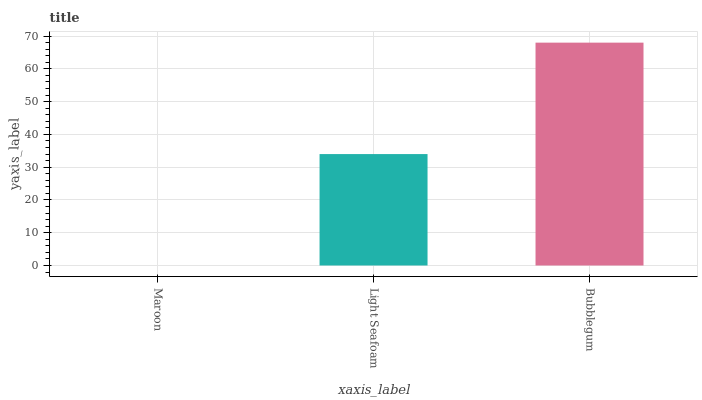Is Maroon the minimum?
Answer yes or no. Yes. Is Bubblegum the maximum?
Answer yes or no. Yes. Is Light Seafoam the minimum?
Answer yes or no. No. Is Light Seafoam the maximum?
Answer yes or no. No. Is Light Seafoam greater than Maroon?
Answer yes or no. Yes. Is Maroon less than Light Seafoam?
Answer yes or no. Yes. Is Maroon greater than Light Seafoam?
Answer yes or no. No. Is Light Seafoam less than Maroon?
Answer yes or no. No. Is Light Seafoam the high median?
Answer yes or no. Yes. Is Light Seafoam the low median?
Answer yes or no. Yes. Is Maroon the high median?
Answer yes or no. No. Is Maroon the low median?
Answer yes or no. No. 